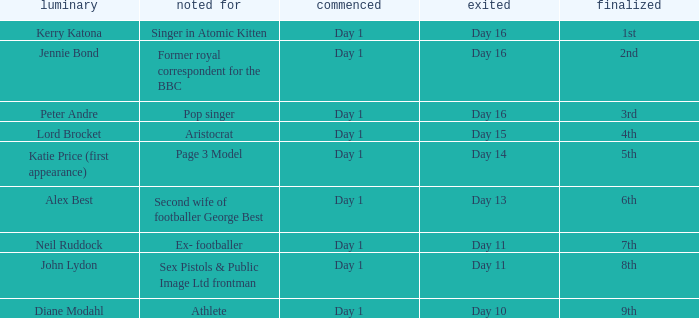Name the finished for exited of day 13 6th. 